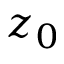<formula> <loc_0><loc_0><loc_500><loc_500>z _ { 0 }</formula> 